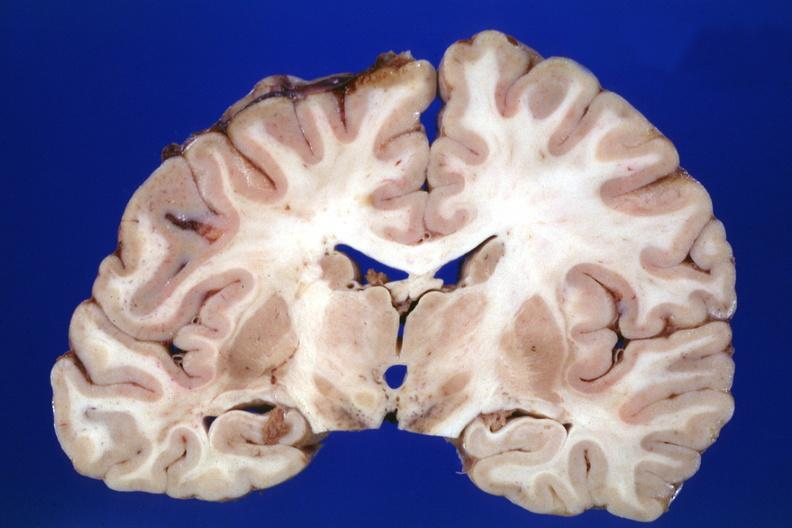was the lesion in the pons?
Answer the question using a single word or phrase. Yes 